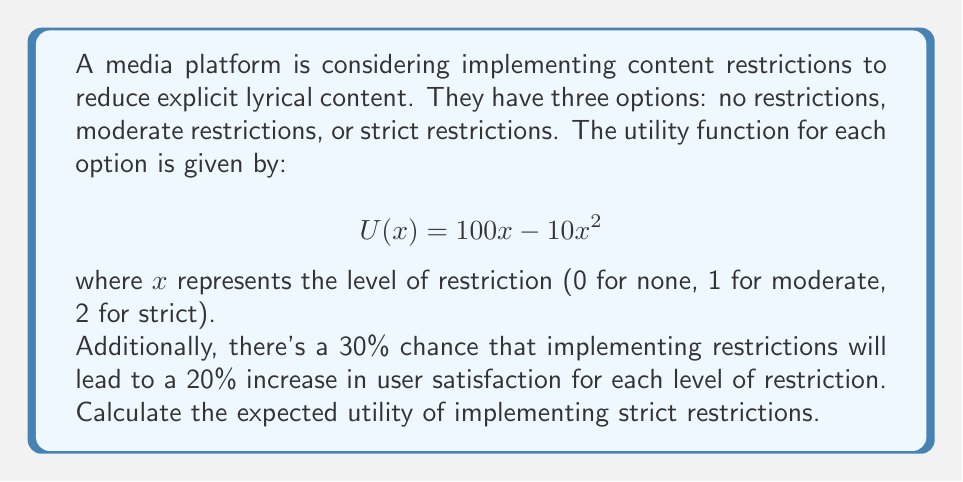Solve this math problem. To solve this problem, we need to follow these steps:

1. Calculate the base utility of strict restrictions:
   $$U(2) = 100(2) - 10(2^2) = 200 - 40 = 160$$

2. Calculate the potential increased utility:
   With a 20% increase per level, strict restrictions (level 2) would have a 40% increase.
   $$U_{increased}(2) = 160 * 1.4 = 224$$

3. Calculate the expected utility:
   The expected utility is the weighted average of the two possible outcomes.
   
   $$E[U] = P(\text{no increase}) * U(\text{no increase}) + P(\text{increase}) * U(\text{increase})$$
   $$E[U] = 0.7 * 160 + 0.3 * 224$$

4. Compute the final result:
   $$E[U] = 112 + 67.2 = 179.2$$

Therefore, the expected utility of implementing strict restrictions is 179.2.
Answer: 179.2 